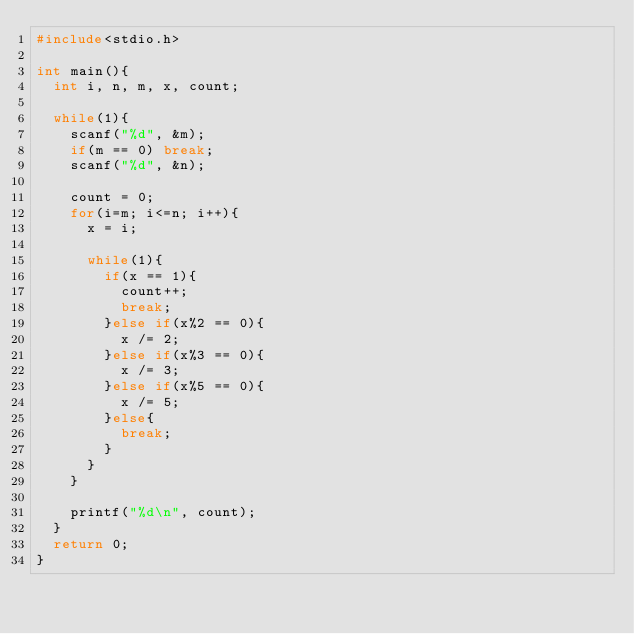Convert code to text. <code><loc_0><loc_0><loc_500><loc_500><_C_>#include<stdio.h>

int main(){
  int i, n, m, x, count;

  while(1){
    scanf("%d", &m);
    if(m == 0) break;
    scanf("%d", &n);
 
    count = 0;
    for(i=m; i<=n; i++){
      x = i;

      while(1){
        if(x == 1){
          count++;
          break;
        }else if(x%2 == 0){
          x /= 2;
        }else if(x%3 == 0){
          x /= 3;
        }else if(x%5 == 0){
          x /= 5;
        }else{
          break;
        }
      }
    }

    printf("%d\n", count);
  }
  return 0;
}</code> 